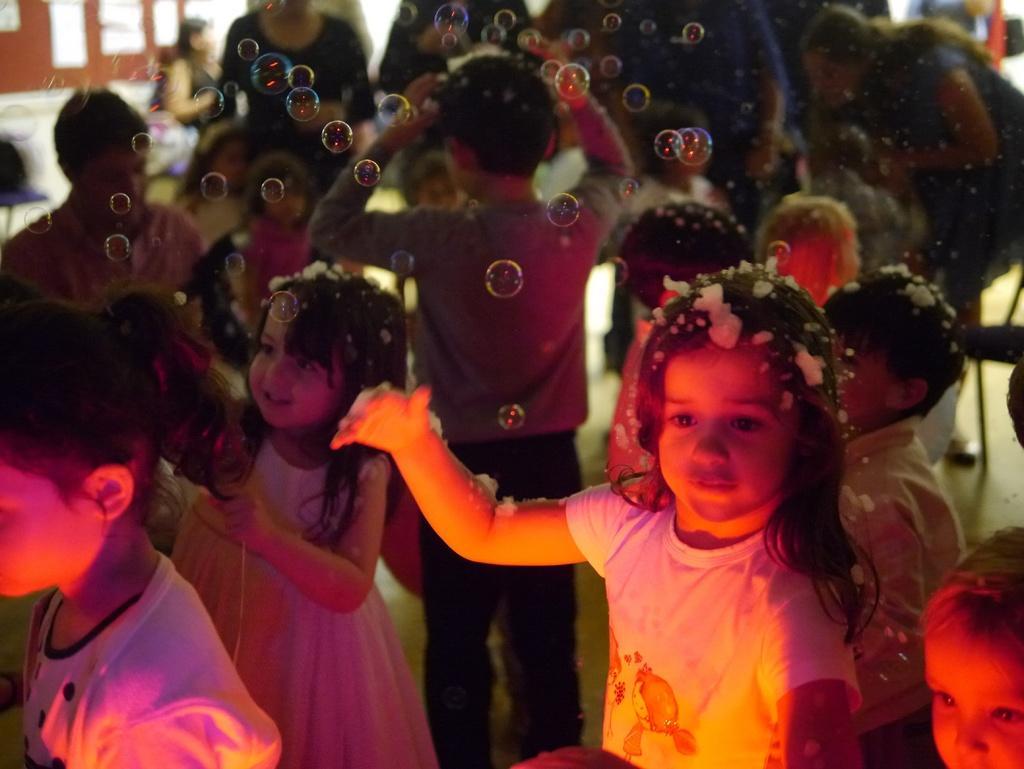Could you give a brief overview of what you see in this image? In the image we can see there are many Children's standing and wearing clothes. Here we can see foam bubbles, the floor and the background is blurred. 